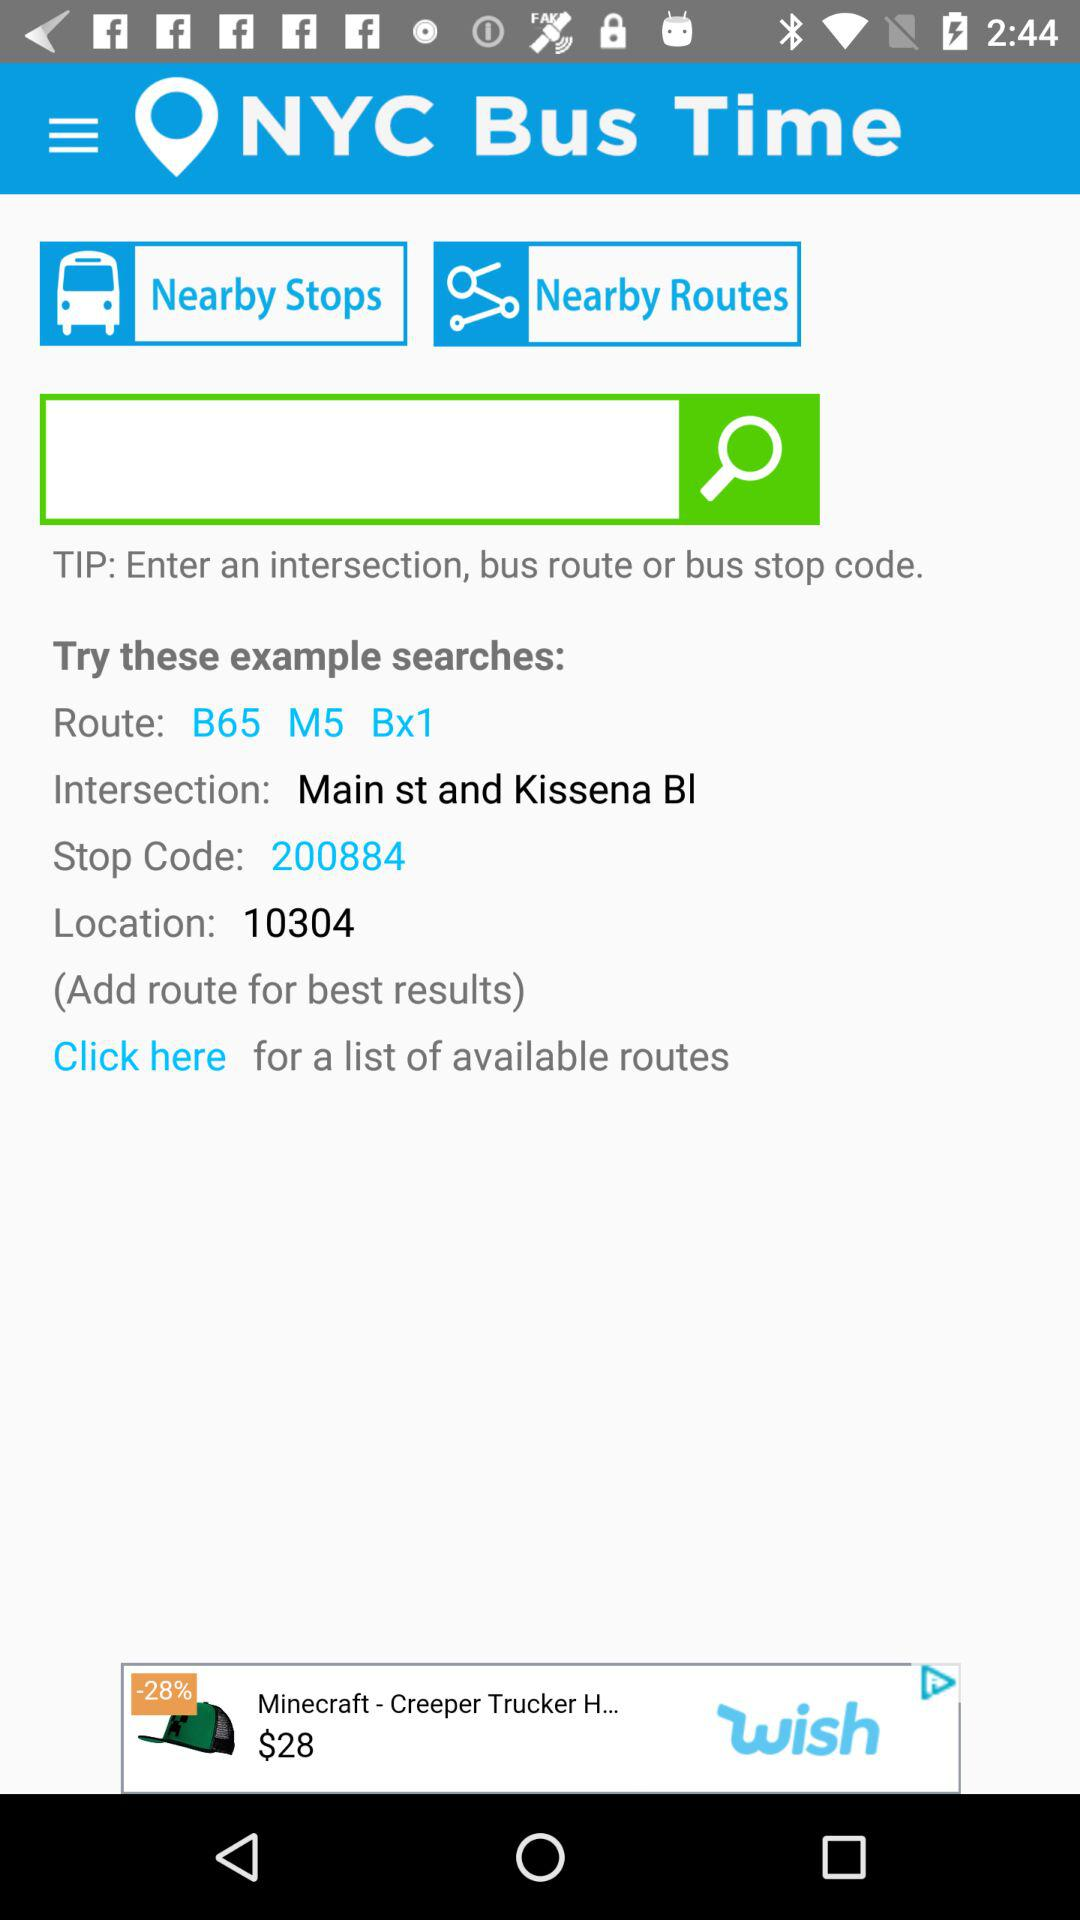What is the route? The route is "B65 MS BX1". 